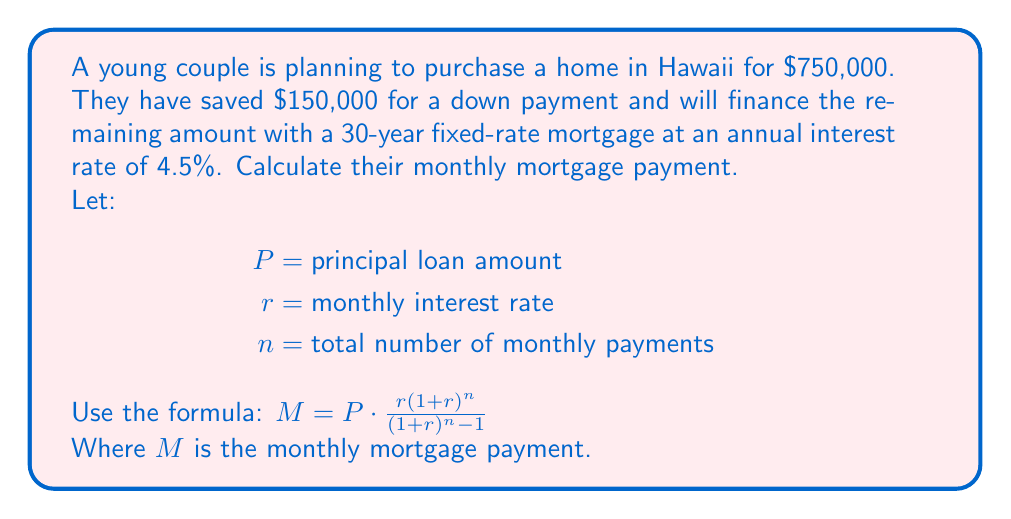Teach me how to tackle this problem. To solve this problem, we'll follow these steps:

1. Calculate the principal loan amount:
   $P = \text{Home price} - \text{Down payment}$
   $P = \$750,000 - \$150,000 = \$600,000$

2. Convert the annual interest rate to a monthly rate:
   $r = \frac{\text{Annual rate}}{12} = \frac{4.5\%}{12} = 0.00375$

3. Calculate the total number of monthly payments:
   $n = \text{Years} \times 12 = 30 \times 12 = 360$

4. Apply the mortgage payment formula:

   $M = P \cdot \frac{r(1+r)^n}{(1+r)^n - 1}$

   $M = 600,000 \cdot \frac{0.00375(1+0.00375)^{360}}{(1+0.00375)^{360} - 1}$

5. Use a calculator to compute the result:
   $M \approx 3,040.47$

Therefore, the monthly mortgage payment for the Hawaiian home will be approximately $3,040.47.
Answer: The monthly mortgage payment for the Hawaiian home will be $3,040.47. 